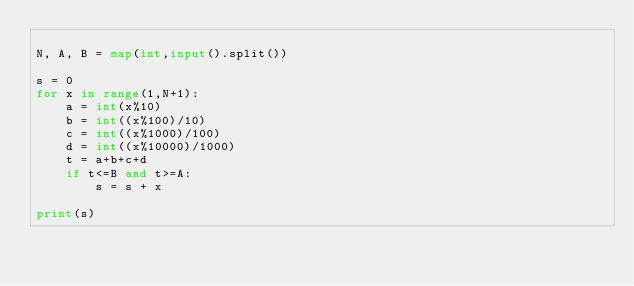Convert code to text. <code><loc_0><loc_0><loc_500><loc_500><_Python_>
N, A, B = map(int,input().split())

s = 0
for x in range(1,N+1):
    a = int(x%10)
    b = int((x%100)/10)
    c = int((x%1000)/100)
    d = int((x%10000)/1000)
    t = a+b+c+d
    if t<=B and t>=A:
        s = s + x

print(s)
</code> 